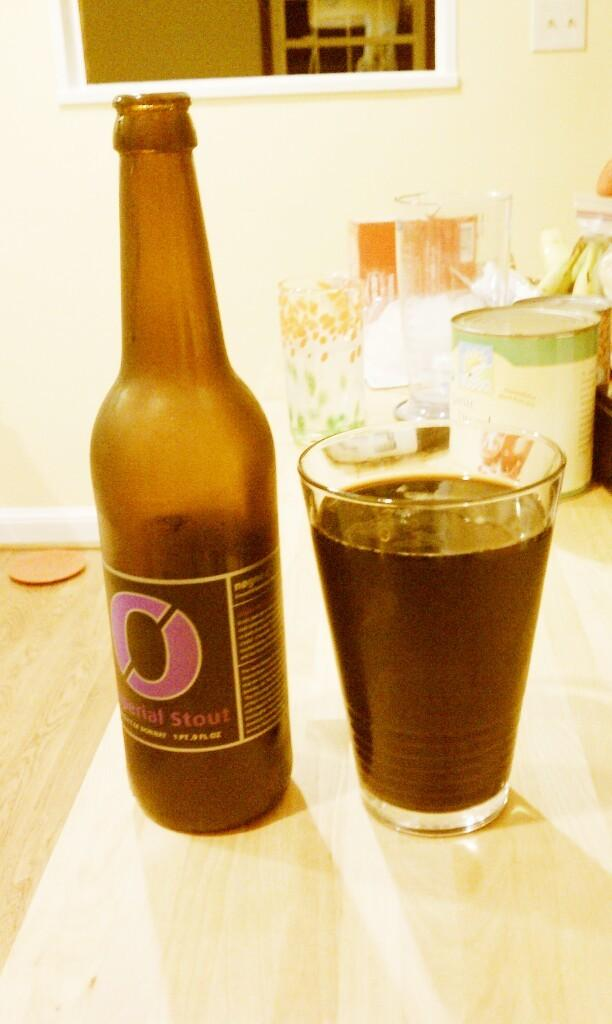Provide a one-sentence caption for the provided image. A bottle of Imperial Stout beer next to a cup of beer. 